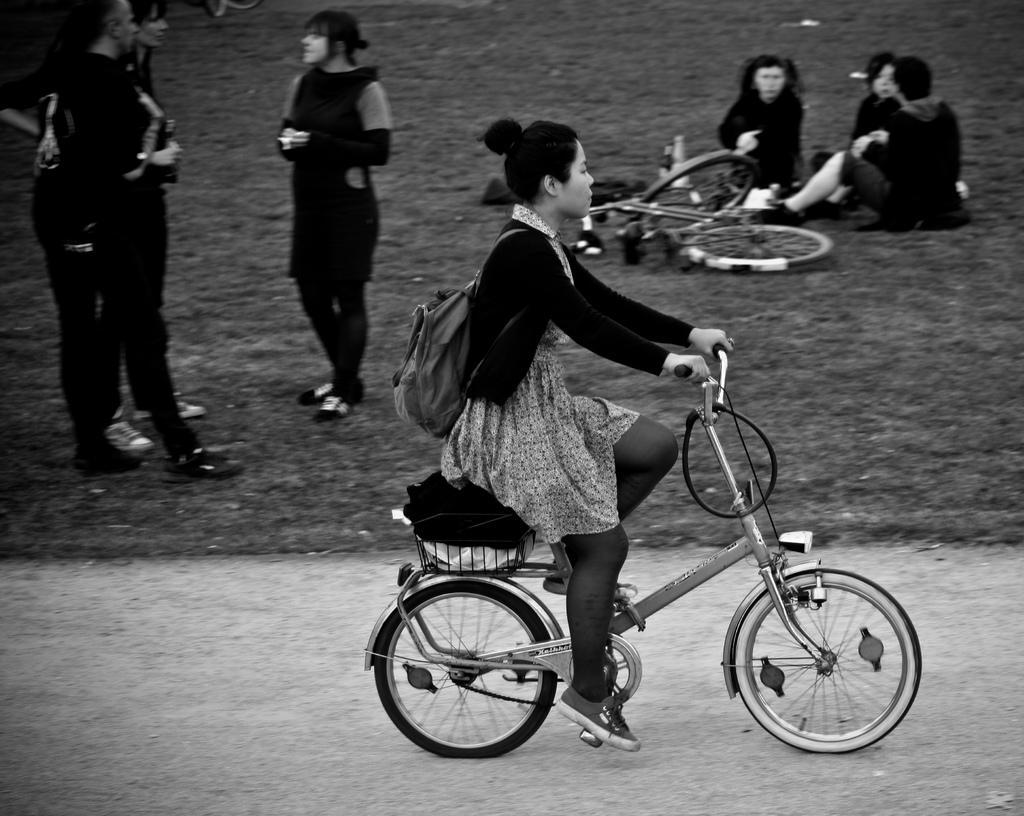Could you give a brief overview of what you see in this image? This picture is clicked outside the city. In front of the picture, we see a girl in black jacket is riding bicycle. She is wearing a bag. Behind her, we see three people standing and talking to each other and on the right top of the picture, we see three women sitting on the floor and we even see a bicycle beside them. 